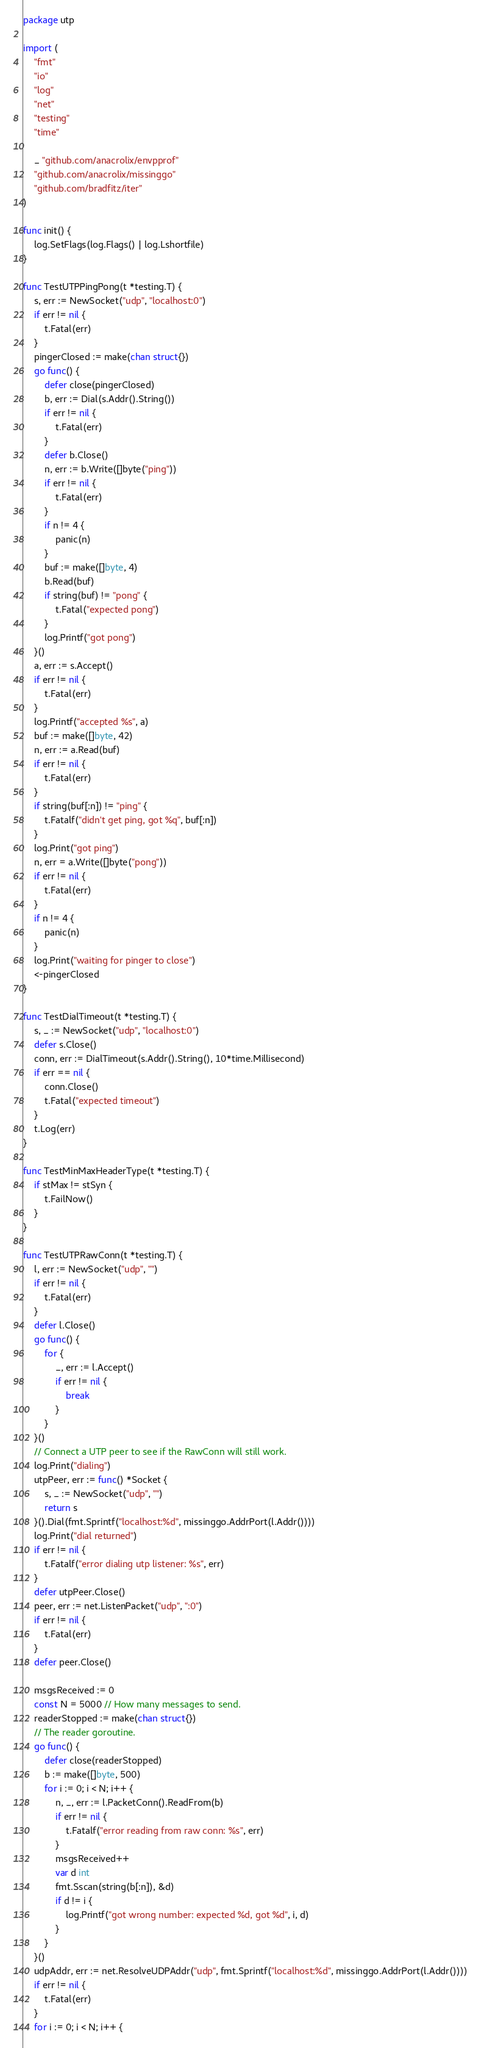Convert code to text. <code><loc_0><loc_0><loc_500><loc_500><_Go_>package utp

import (
	"fmt"
	"io"
	"log"
	"net"
	"testing"
	"time"

	_ "github.com/anacrolix/envpprof"
	"github.com/anacrolix/missinggo"
	"github.com/bradfitz/iter"
)

func init() {
	log.SetFlags(log.Flags() | log.Lshortfile)
}

func TestUTPPingPong(t *testing.T) {
	s, err := NewSocket("udp", "localhost:0")
	if err != nil {
		t.Fatal(err)
	}
	pingerClosed := make(chan struct{})
	go func() {
		defer close(pingerClosed)
		b, err := Dial(s.Addr().String())
		if err != nil {
			t.Fatal(err)
		}
		defer b.Close()
		n, err := b.Write([]byte("ping"))
		if err != nil {
			t.Fatal(err)
		}
		if n != 4 {
			panic(n)
		}
		buf := make([]byte, 4)
		b.Read(buf)
		if string(buf) != "pong" {
			t.Fatal("expected pong")
		}
		log.Printf("got pong")
	}()
	a, err := s.Accept()
	if err != nil {
		t.Fatal(err)
	}
	log.Printf("accepted %s", a)
	buf := make([]byte, 42)
	n, err := a.Read(buf)
	if err != nil {
		t.Fatal(err)
	}
	if string(buf[:n]) != "ping" {
		t.Fatalf("didn't get ping, got %q", buf[:n])
	}
	log.Print("got ping")
	n, err = a.Write([]byte("pong"))
	if err != nil {
		t.Fatal(err)
	}
	if n != 4 {
		panic(n)
	}
	log.Print("waiting for pinger to close")
	<-pingerClosed
}

func TestDialTimeout(t *testing.T) {
	s, _ := NewSocket("udp", "localhost:0")
	defer s.Close()
	conn, err := DialTimeout(s.Addr().String(), 10*time.Millisecond)
	if err == nil {
		conn.Close()
		t.Fatal("expected timeout")
	}
	t.Log(err)
}

func TestMinMaxHeaderType(t *testing.T) {
	if stMax != stSyn {
		t.FailNow()
	}
}

func TestUTPRawConn(t *testing.T) {
	l, err := NewSocket("udp", "")
	if err != nil {
		t.Fatal(err)
	}
	defer l.Close()
	go func() {
		for {
			_, err := l.Accept()
			if err != nil {
				break
			}
		}
	}()
	// Connect a UTP peer to see if the RawConn will still work.
	log.Print("dialing")
	utpPeer, err := func() *Socket {
		s, _ := NewSocket("udp", "")
		return s
	}().Dial(fmt.Sprintf("localhost:%d", missinggo.AddrPort(l.Addr())))
	log.Print("dial returned")
	if err != nil {
		t.Fatalf("error dialing utp listener: %s", err)
	}
	defer utpPeer.Close()
	peer, err := net.ListenPacket("udp", ":0")
	if err != nil {
		t.Fatal(err)
	}
	defer peer.Close()

	msgsReceived := 0
	const N = 5000 // How many messages to send.
	readerStopped := make(chan struct{})
	// The reader goroutine.
	go func() {
		defer close(readerStopped)
		b := make([]byte, 500)
		for i := 0; i < N; i++ {
			n, _, err := l.PacketConn().ReadFrom(b)
			if err != nil {
				t.Fatalf("error reading from raw conn: %s", err)
			}
			msgsReceived++
			var d int
			fmt.Sscan(string(b[:n]), &d)
			if d != i {
				log.Printf("got wrong number: expected %d, got %d", i, d)
			}
		}
	}()
	udpAddr, err := net.ResolveUDPAddr("udp", fmt.Sprintf("localhost:%d", missinggo.AddrPort(l.Addr())))
	if err != nil {
		t.Fatal(err)
	}
	for i := 0; i < N; i++ {</code> 